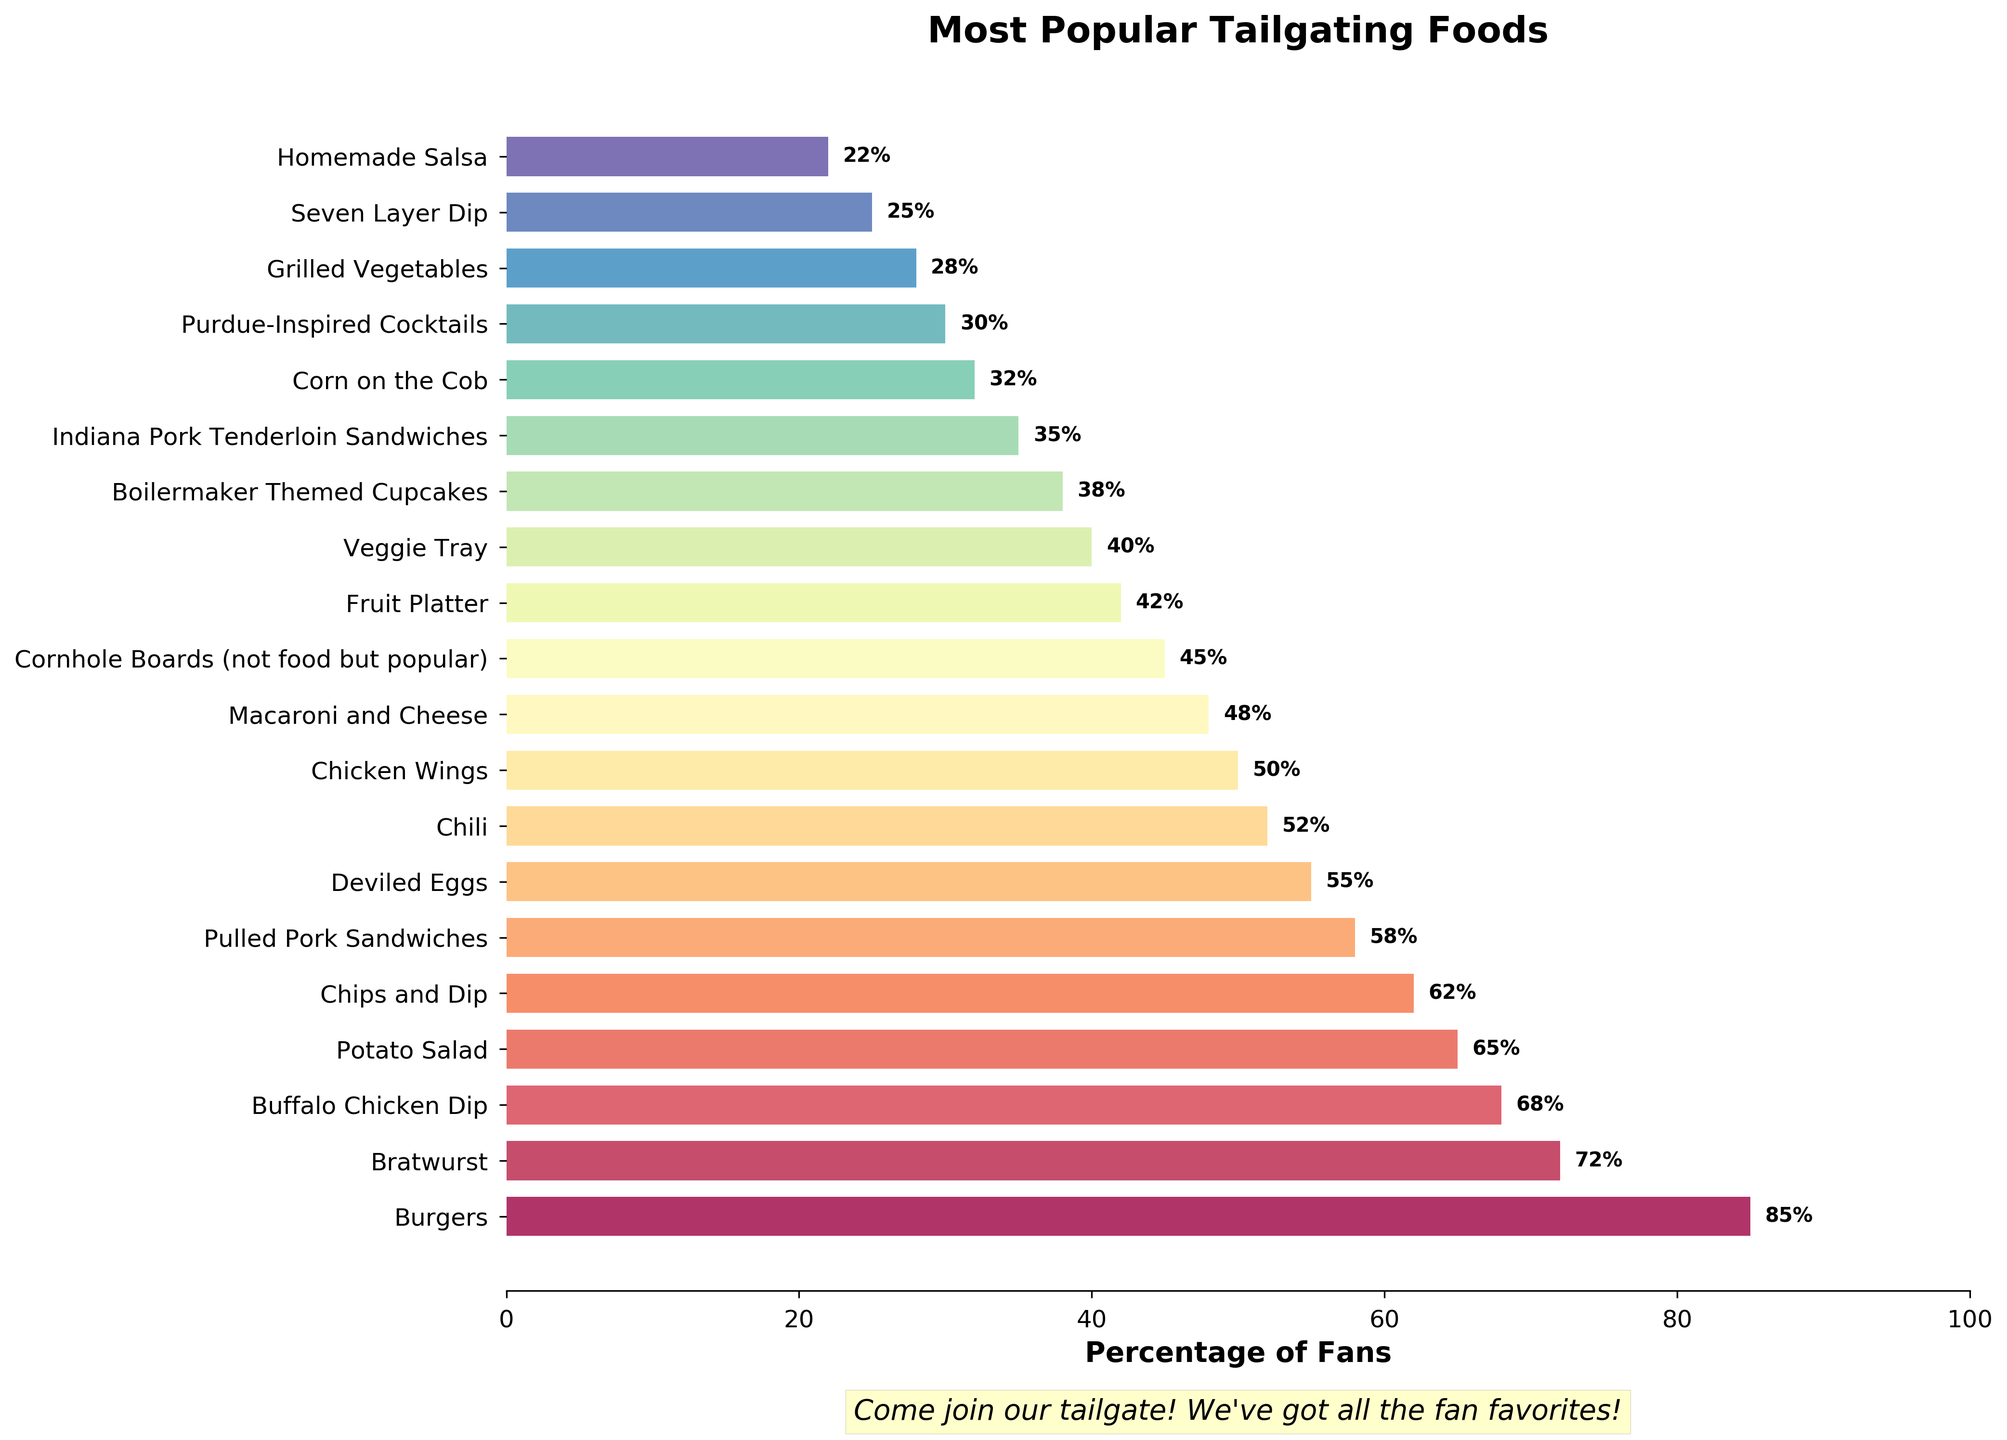What's the most popular tailgating food? The chart shows the food items and their corresponding percentages of fans who bring them. The food with the highest percentage is the most popular.
Answer: Burgers What's the least popular tailgating food? The chart shows the food items and their corresponding percentages of fans who bring them. The food with the lowest percentage is the least popular.
Answer: Homemade Salsa How many food items are brought by at least 60% of fans? Count the number of food items with percentages 60 or above from the bar chart.
Answer: 5 Are there more fans bringing Burgers or Chicken Wings? Compare the percentages of fans bringing Burgers (85%) and Chicken Wings (50%) from the chart.
Answer: Burgers What’s the combined percentage of fans bringing Potato Salad and Veggie Tray? Add the percentages of fans bringing Potato Salad (65%) and Veggie Tray (40%). 65 + 40 = 105
Answer: 105 Which food item has a higher percentage: Buffalo Chicken Dip or Pulled Pork Sandwiches? Compare the percentages of fans bringing Buffalo Chicken Dip (68%) and Pulled Pork Sandwiches (58%) from the chart.
Answer: Buffalo Chicken Dip Which item, though not a food, is still popular at tailgating events? The chart indicates Cornhole Boards with a note that it is not food but popular.
Answer: Cornhole Boards How many food items have a percentage between 30% and 50%? Count the number of food items with percentages between 30 and 50 inclusive from the chart.
Answer: 6 By how much does the percentage of fans bringing Bratwurst exceed that of Chili? Subtract the percentage of fans bringing Chili (52%) from the percentage of fans bringing Bratwurst (72%). 72 - 52 = 20
Answer: 20 What’s the difference in percentages between the most and least popular food items? Subtract the percentage of the least popular food item (Homemade Salsa 22%) from the most popular food item (Burgers 85%). 85 - 22 = 63
Answer: 63 